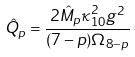<formula> <loc_0><loc_0><loc_500><loc_500>\hat { Q } _ { p } = \frac { 2 \hat { M } _ { p } \kappa _ { 1 0 } ^ { 2 } g ^ { 2 } } { ( 7 - p ) \Omega _ { 8 - p } }</formula> 